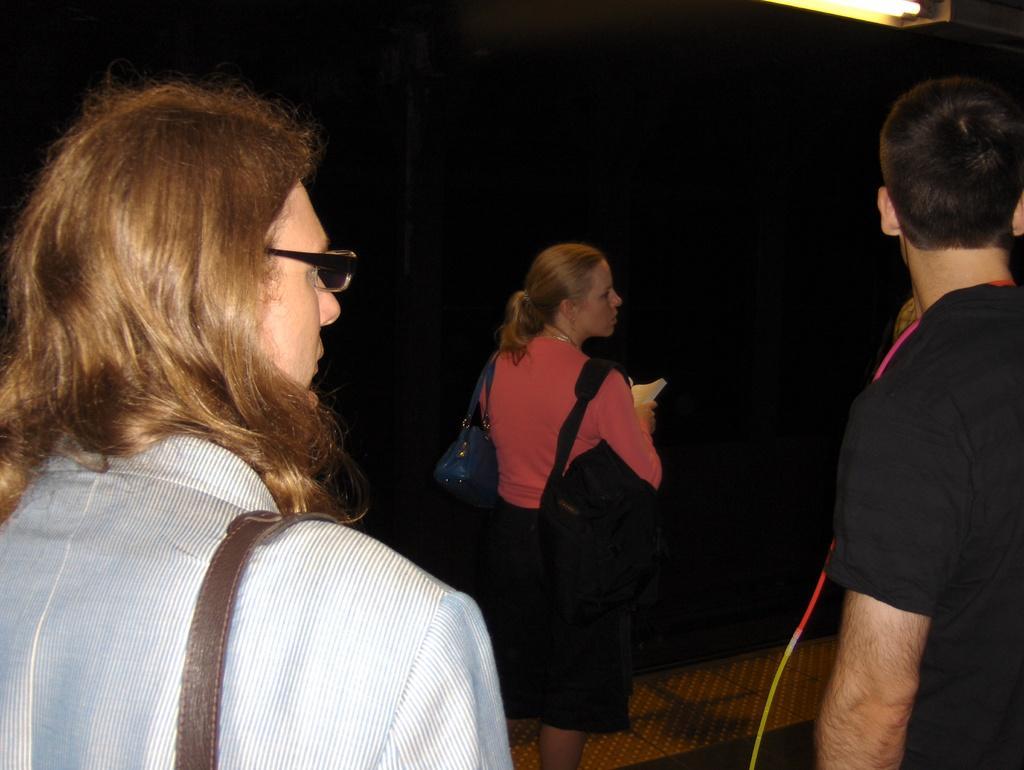Can you describe this image briefly? Here I can see a man and two women are standing. The women are wearing bags and looking at the right side. The background is in black color. 